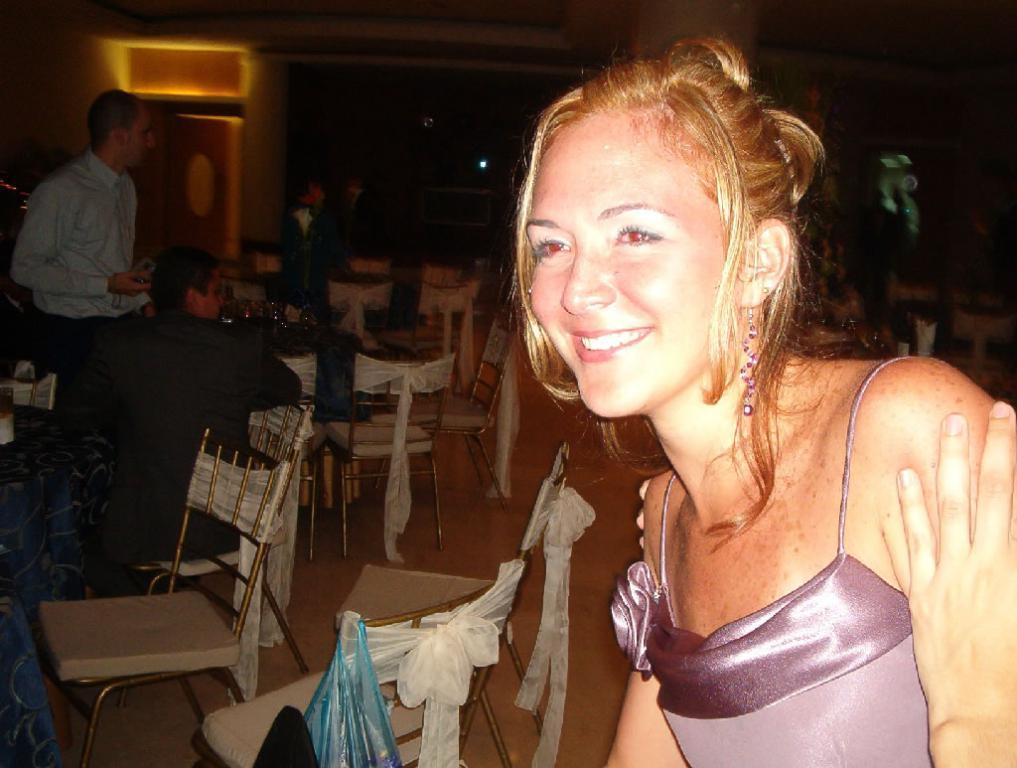Can you describe this image briefly? There is a room. There is a group of people. They are sitting on a chairs. On the left side we have a person. He is standing. There is a table,. There is a glass on a table. On the right side we have a woman. She is wearing a earrings and she is smiling,. 